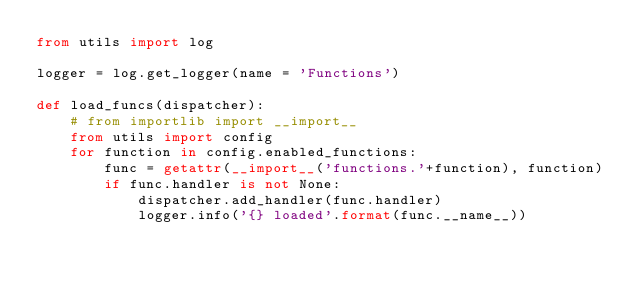<code> <loc_0><loc_0><loc_500><loc_500><_Python_>from utils import log

logger = log.get_logger(name = 'Functions')

def load_funcs(dispatcher):
    # from importlib import __import__
    from utils import config
    for function in config.enabled_functions:
        func = getattr(__import__('functions.'+function), function)
        if func.handler is not None:
            dispatcher.add_handler(func.handler)
            logger.info('{} loaded'.format(func.__name__))</code> 